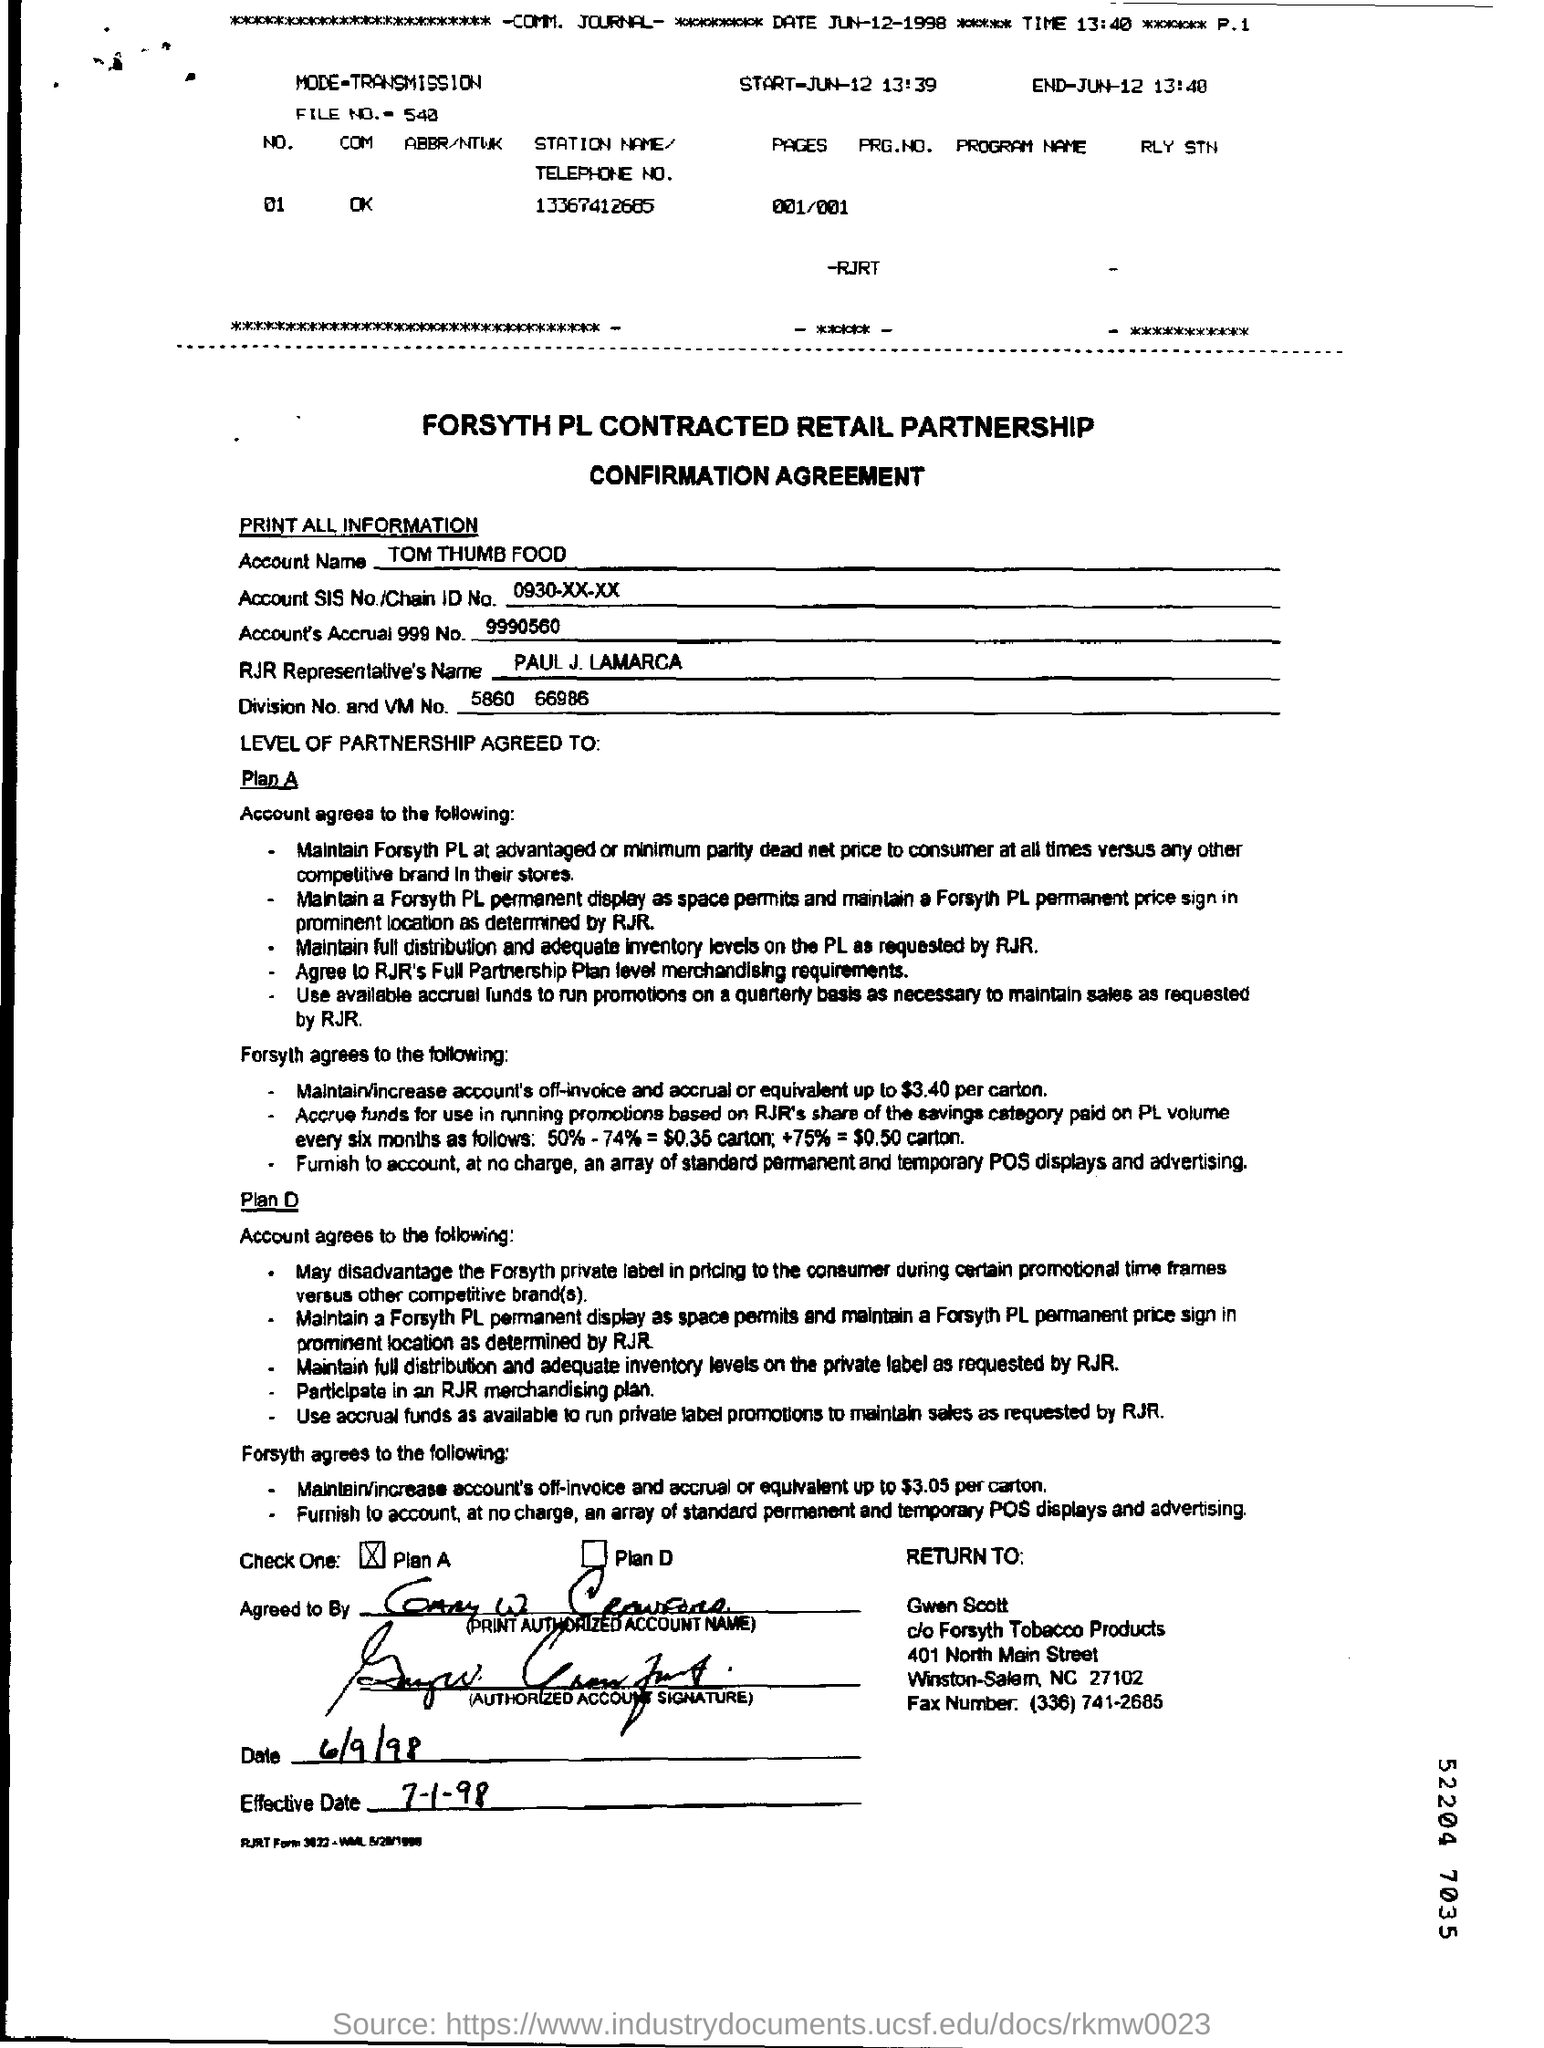What is the account name?
Offer a very short reply. TOM THUMB FOOD. What is the account SIS No./Chain ID No.?
Ensure brevity in your answer.  0930-XX-XX. What is the name of the RJR Representative?
Make the answer very short. PAUL J. LAMARCA. 